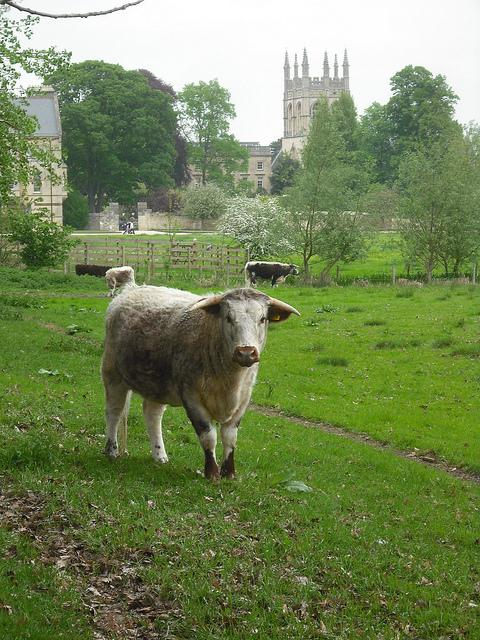What type of animal is present on the grass? cow 